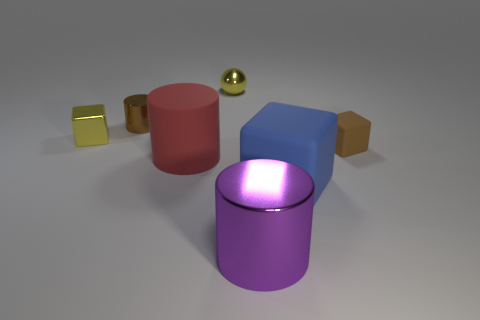What is the material of the tiny ball that is the same color as the shiny block?
Your answer should be compact. Metal. How many large red rubber things have the same shape as the large purple object?
Provide a short and direct response. 1. What material is the other big thing that is the same shape as the large purple thing?
Offer a terse response. Rubber. How many other things are there of the same color as the shiny ball?
Provide a short and direct response. 1. How many yellow objects are either metallic blocks or tiny rubber objects?
Your response must be concise. 1. The tiny thing that is in front of the tiny brown metal thing and on the left side of the red cylinder is what color?
Your answer should be very brief. Yellow. Is the tiny brown object left of the tiny brown matte object made of the same material as the yellow object to the left of the small yellow sphere?
Provide a short and direct response. Yes. Are there more large purple cylinders in front of the large blue cube than purple metallic cylinders behind the large purple metallic cylinder?
Make the answer very short. Yes. There is a purple shiny thing that is the same size as the red matte object; what is its shape?
Offer a terse response. Cylinder. How many objects are big gray spheres or metallic objects behind the tiny yellow cube?
Make the answer very short. 2. 